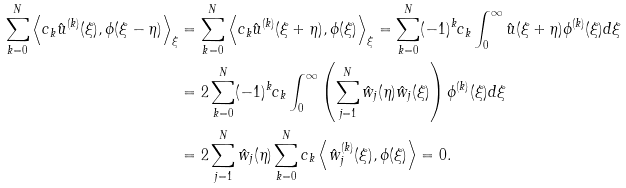Convert formula to latex. <formula><loc_0><loc_0><loc_500><loc_500>\sum _ { k = 0 } ^ { N } \left \langle c _ { k } \hat { u } ^ { ( k ) } ( \xi ) , \phi ( \xi - \eta ) \right \rangle _ { \xi } & = \sum _ { k = 0 } ^ { N } \left \langle c _ { k } \hat { u } ^ { ( k ) } ( \xi + \eta ) , \phi ( \xi ) \right \rangle _ { \xi } = \sum _ { k = 0 } ^ { N } ( - 1 ) ^ { k } c _ { k } \int _ { 0 } ^ { \infty } \hat { u } ( \xi + \eta ) \phi ^ { ( k ) } ( \xi ) d \xi \\ & = 2 \sum _ { k = 0 } ^ { N } ( - 1 ) ^ { k } c _ { k } \int _ { 0 } ^ { \infty } \left ( \sum _ { j = 1 } ^ { N } \hat { w } _ { j } ( \eta ) \hat { w } _ { j } ( \xi ) \right ) \phi ^ { ( k ) } ( \xi ) d \xi \\ & = 2 \sum _ { j = 1 } ^ { N } \hat { w } _ { j } ( \eta ) \sum _ { k = 0 } ^ { N } c _ { k } \left \langle \hat { w } _ { j } ^ { ( k ) } ( \xi ) , \phi ( \xi ) \right \rangle = 0 .</formula> 